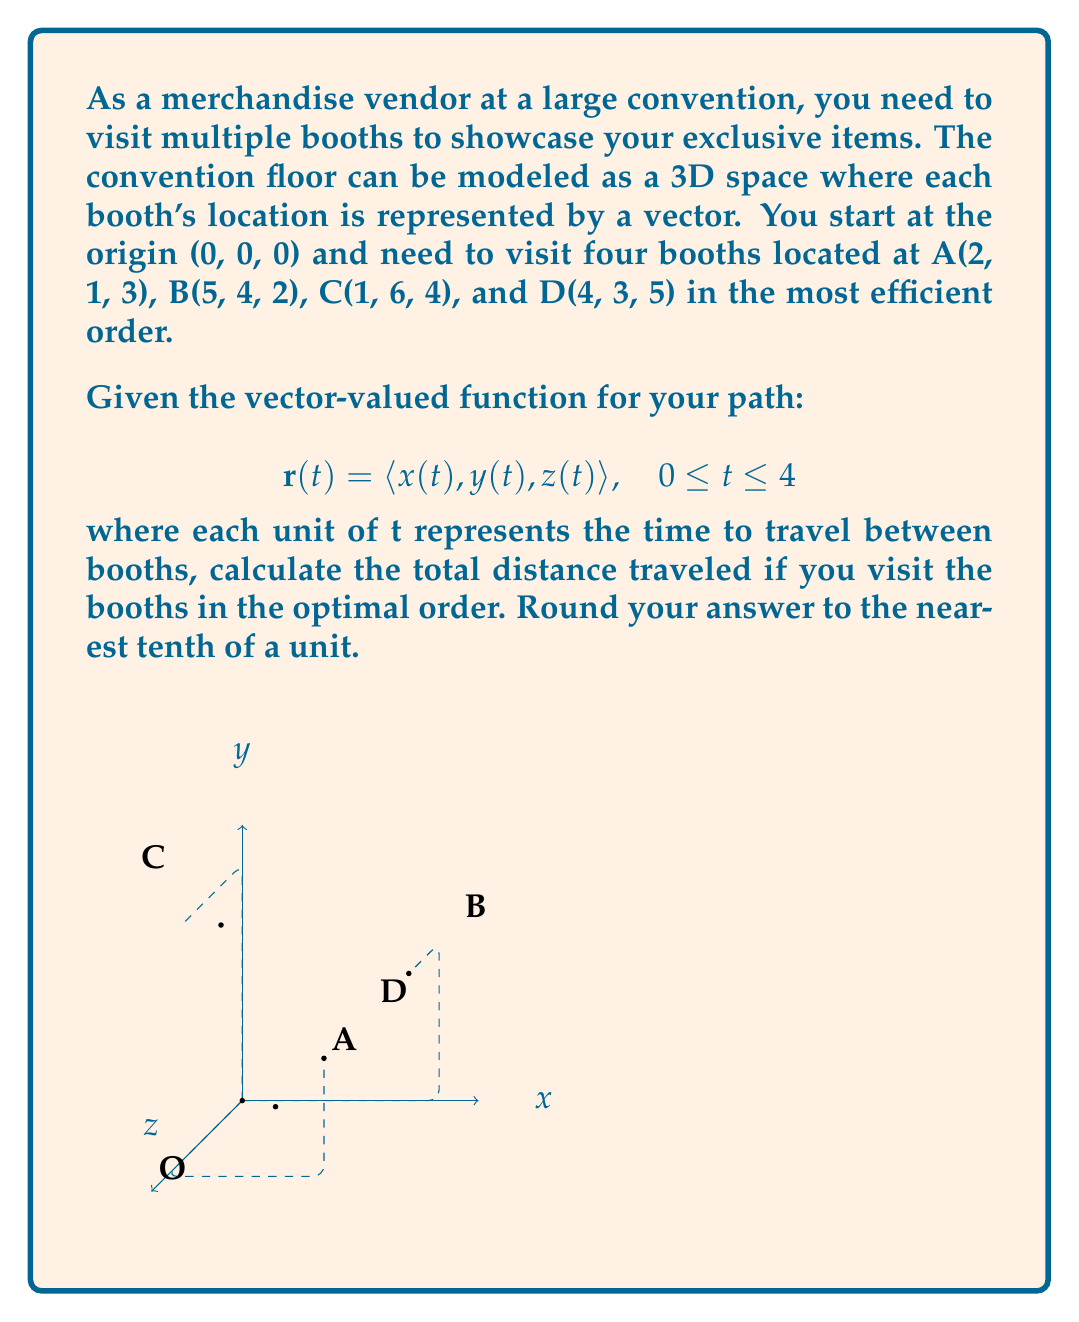Can you solve this math problem? To solve this problem, we'll follow these steps:

1) First, we need to determine the optimal order to visit the booths. The most efficient path is the one that minimizes the total distance traveled. We can calculate this by finding the shortest path that visits all points once and returns to the origin.

2) To find the shortest path, we'll calculate the distances between all pairs of points (including the origin) and use the nearest neighbor algorithm as a heuristic approach.

3) Distances between points:
   O to A: $\sqrt{2^2 + 1^2 + 3^2} = \sqrt{14}$
   O to B: $\sqrt{5^2 + 4^2 + 2^2} = \sqrt{45}$
   O to C: $\sqrt{1^2 + 6^2 + 4^2} = \sqrt{53}$
   O to D: $\sqrt{4^2 + 3^2 + 5^2} = \sqrt{50}$
   A to B: $\sqrt{3^2 + 3^2 + (-1)^2} = \sqrt{19}$
   A to C: $\sqrt{(-1)^2 + 5^2 + 1^2} = \sqrt{27}$
   A to D: $\sqrt{2^2 + 2^2 + 2^2} = \sqrt{12}$
   B to C: $\sqrt{(-4)^2 + 2^2 + 2^2} = \sqrt{24}$
   B to D: $\sqrt{(-1)^2 + (-1)^2 + 3^2} = \sqrt{11}$
   C to D: $\sqrt{3^2 + (-3)^2 + 1^2} = \sqrt{19}$

4) Using the nearest neighbor algorithm starting from O:
   O → A (closest to O)
   A → D (closest to A)
   D → B (closest to D)
   B → C (only remaining point)
   C → O (return to origin)

5) Now that we have the optimal path, we can define our vector-valued function:

   $$\mathbf{r}(t) = \begin{cases}
   \langle 2t, t, 3t \rangle, & 0 \leq t < 1 \\
   \langle 2 + 2(t-1), 1 + 2(t-1), 3 + 2(t-1) \rangle, & 1 \leq t < 2 \\
   \langle 4 + (t-2), 3 + (t-2), 5 + (-3)(t-2) \rangle, & 2 \leq t < 3 \\
   \langle 5 + (-4)(t-3), 4 + 2(t-3), 2 + 2(t-3) \rangle, & 3 \leq t \leq 4
   \end{cases}$$

6) To calculate the total distance, we need to find the length of each segment:

   O to A: $\sqrt{14}$
   A to D: $\sqrt{12}$
   D to B: $\sqrt{11}$
   B to C: $\sqrt{24}$
   C to O: $\sqrt{53}$

7) Total distance = $\sqrt{14} + \sqrt{12} + \sqrt{11} + \sqrt{24} + \sqrt{53} \approx 22.6$ units
Answer: 22.6 units 